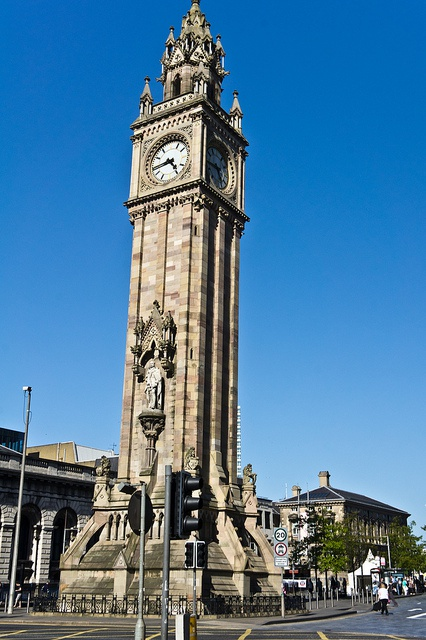Describe the objects in this image and their specific colors. I can see traffic light in blue, black, gray, darkgray, and darkblue tones, clock in blue, white, black, beige, and darkgray tones, clock in blue, black, darkblue, and gray tones, people in blue, black, white, and gray tones, and traffic light in blue, black, white, darkgray, and gray tones in this image. 